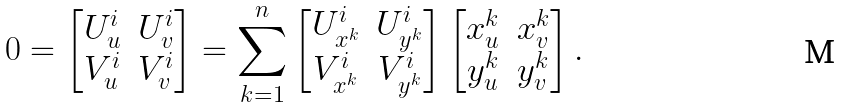Convert formula to latex. <formula><loc_0><loc_0><loc_500><loc_500>0 = \begin{bmatrix} U ^ { i } _ { u } & U ^ { i } _ { v } \\ V ^ { i } _ { u } & V ^ { i } _ { v } \end{bmatrix} = \sum _ { k = 1 } ^ { n } \begin{bmatrix} U ^ { i } _ { x ^ { k } } & U ^ { i } _ { y ^ { k } } \\ V ^ { i } _ { x ^ { k } } & V ^ { i } _ { y ^ { k } } \end{bmatrix} \begin{bmatrix} x ^ { k } _ { u } & x ^ { k } _ { v } \\ y ^ { k } _ { u } & y ^ { k } _ { v } \end{bmatrix} .</formula> 